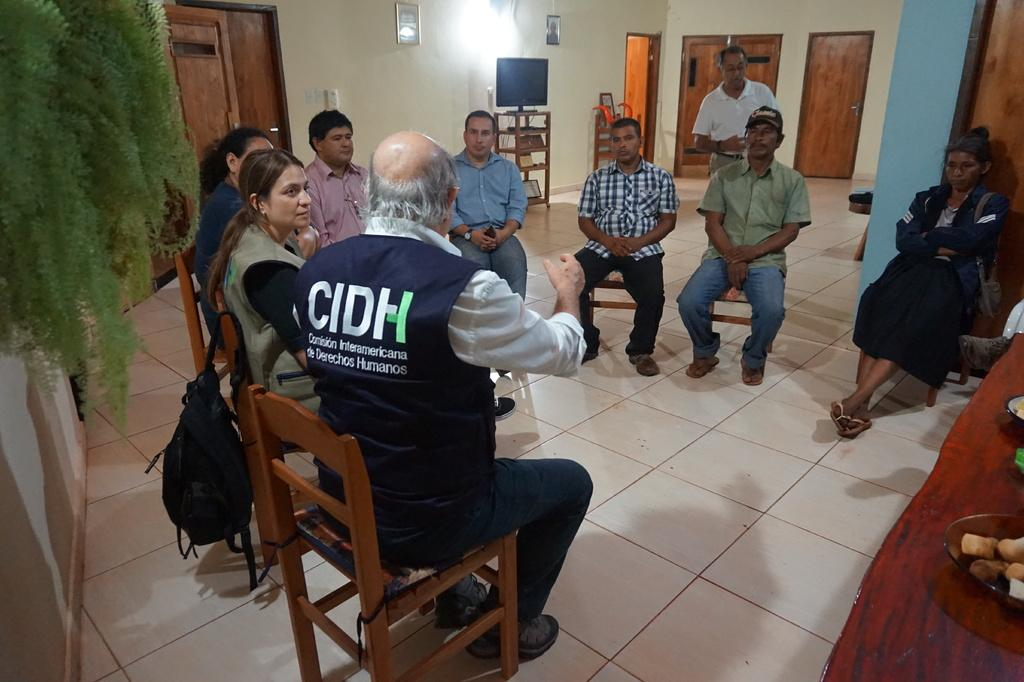What are the people in the image doing? The people in the image are sitting on chairs. Can you describe the man in the background of the image? There is a man standing in the background of the image. What electronic device is present in the image? There is a television in the image. What type of decoration can be seen on the wall in the image? There are frames on the wall in the image. How many rings are visible on the man's fingers in the image? There are no rings visible on the man's fingers in the image. What type of train can be seen passing by in the image? There is no train present in the image. 